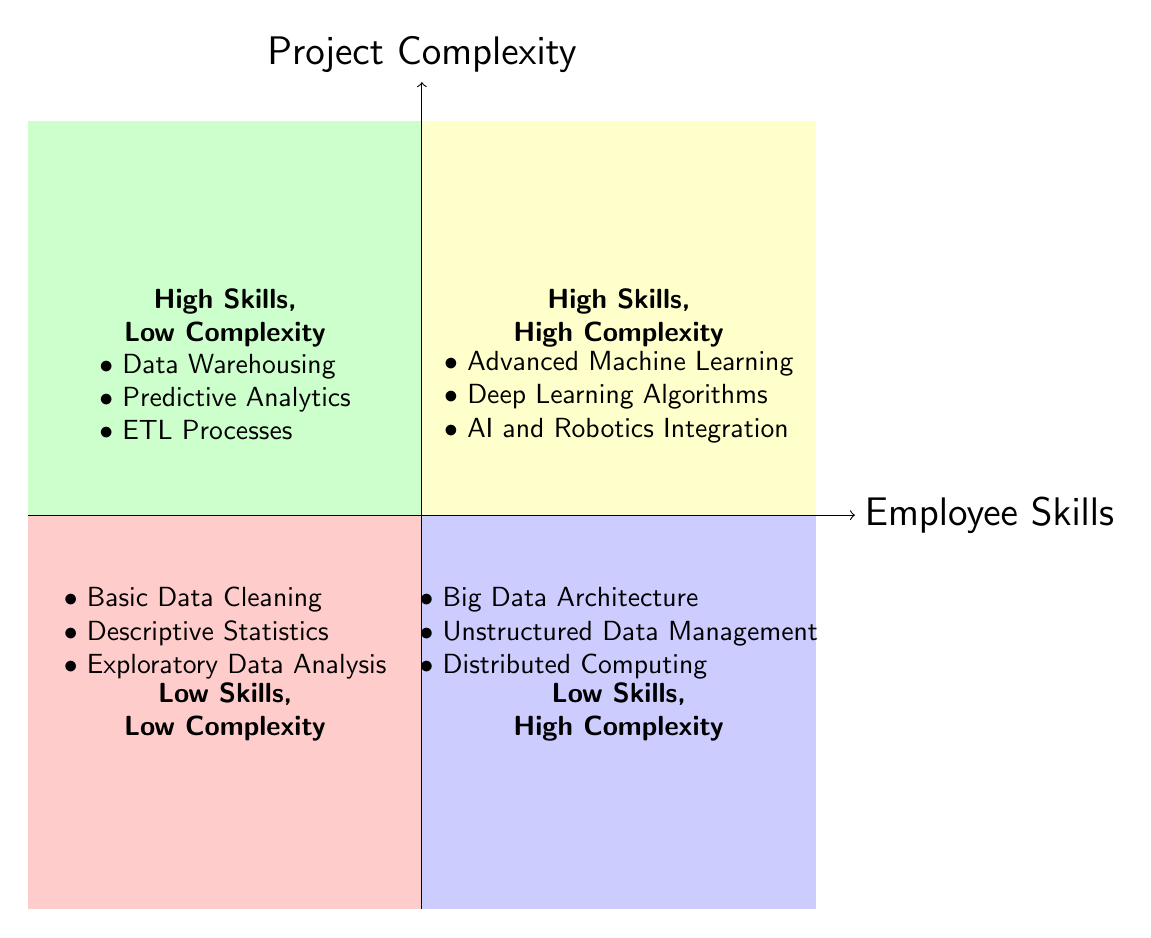What are the examples listed in the High Skills, High Complexity quadrant? The quadrant labeled "High Skills, High Complexity" includes the examples of "Advanced Machine Learning," "Deep Learning Algorithms," and "AI and Robotics Integration."
Answer: Advanced Machine Learning, Deep Learning Algorithms, AI and Robotics Integration How many quadrants are there in the diagram? The diagram consists of four quadrants that represent different combinations of employee skills and project complexity: High Skills, High Complexity; High Skills, Low Complexity; Low Skills, High Complexity; Low Skills, Low Complexity.
Answer: Four Which quadrant contains examples of Basic Data Cleaning? Basic Data Cleaning is listed in the quadrant labeled "Low Skills, Low Complexity," which is located in the bottom-left section of the chart.
Answer: Low Skills, Low Complexity What is the main theme represented by the vertical axis? The vertical axis of the diagram represents "Project Complexity," indicating the complexity level of projects undertaken by employees.
Answer: Project Complexity Identify the quadrant with examples related to Big Data Architecture. The examples of Big Data Architecture are found in the "Low Skills, High Complexity" quadrant, which is located in the bottom-right section of the diagram.
Answer: Low Skills, High Complexity What can be inferred about the relationship between employee skills and project complexity in this chart? The chart suggests that as project complexity increases, it often requires higher employee skills. This is seen in the quadrants on the top half where skills are high and complexity is either high or low.
Answer: Higher skills required for complex projects Name one example listed under High Skills, Low Complexity. One example listed in the "High Skills, Low Complexity" quadrant is "Data Warehousing."
Answer: Data Warehousing What is the color of the Low Skills, High Complexity quadrant? The Low Skills, High Complexity quadrant is colored in light blue, which differentiates it from the other quadrants in the diagram.
Answer: Light blue How does the complexity change as employee skills decrease according to the diagram? As employee skills decrease (moving leftward), project complexity increases from Low Complexity to High Complexity, indicating a trend where less skilled employees are expected to tackle more complex projects, which may not be realistic.
Answer: Complexity increases 